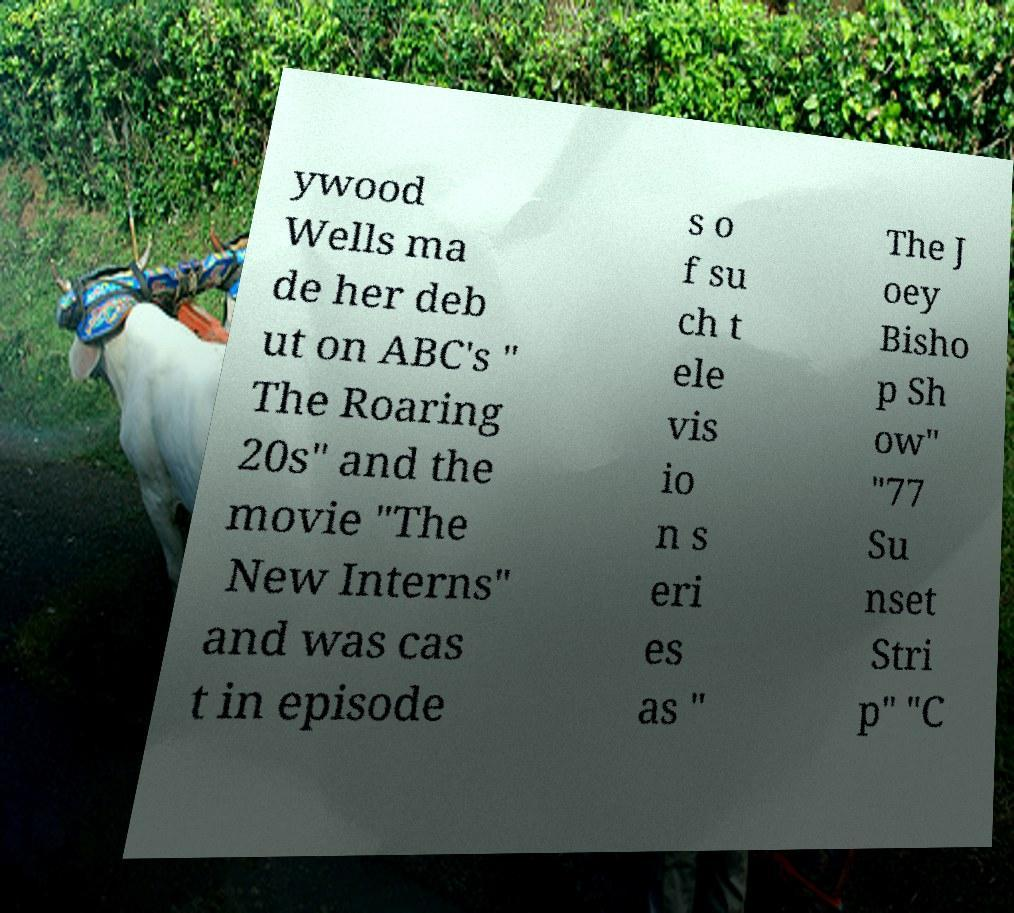Can you read and provide the text displayed in the image?This photo seems to have some interesting text. Can you extract and type it out for me? ywood Wells ma de her deb ut on ABC's " The Roaring 20s" and the movie "The New Interns" and was cas t in episode s o f su ch t ele vis io n s eri es as " The J oey Bisho p Sh ow" "77 Su nset Stri p" "C 